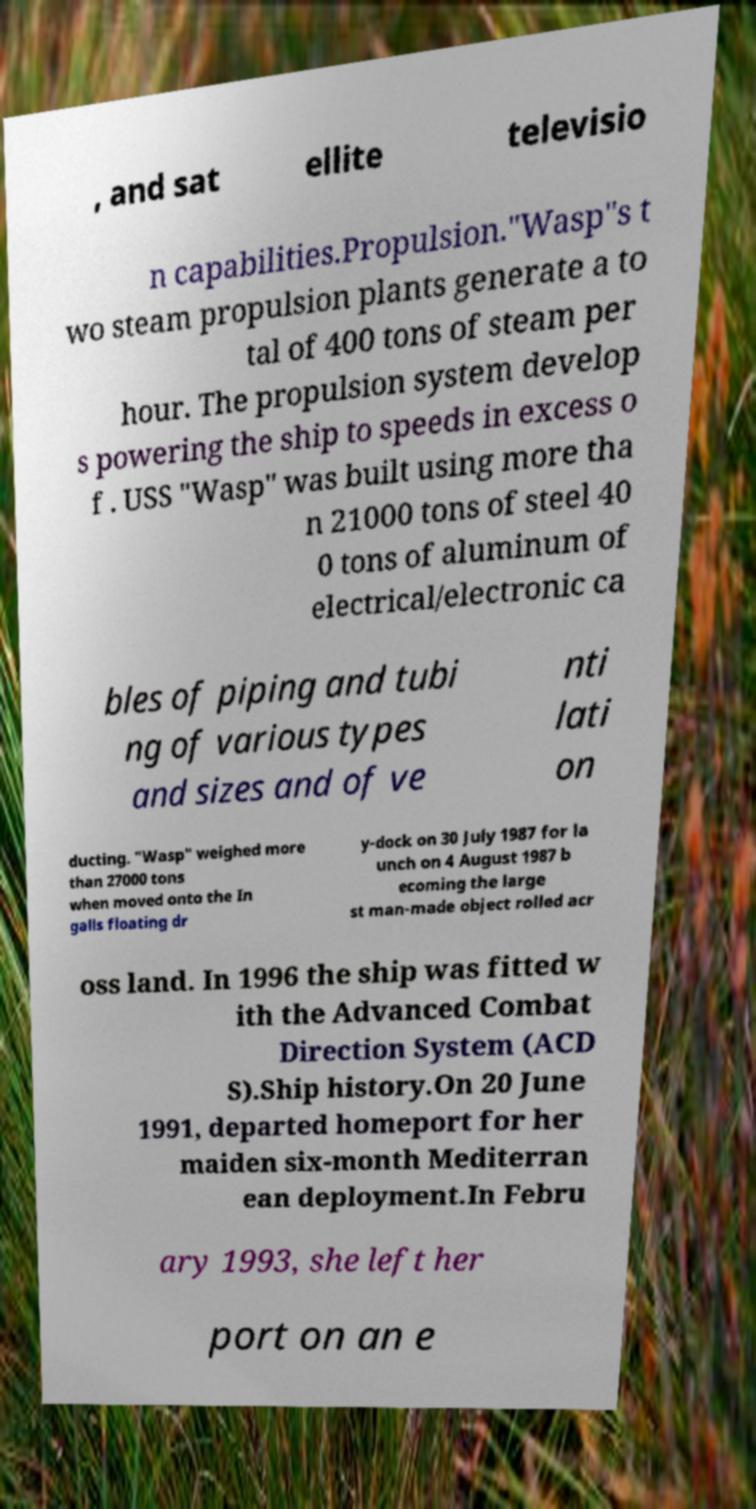Could you extract and type out the text from this image? , and sat ellite televisio n capabilities.Propulsion."Wasp"s t wo steam propulsion plants generate a to tal of 400 tons of steam per hour. The propulsion system develop s powering the ship to speeds in excess o f . USS "Wasp" was built using more tha n 21000 tons of steel 40 0 tons of aluminum of electrical/electronic ca bles of piping and tubi ng of various types and sizes and of ve nti lati on ducting. "Wasp" weighed more than 27000 tons when moved onto the In galls floating dr y-dock on 30 July 1987 for la unch on 4 August 1987 b ecoming the large st man-made object rolled acr oss land. In 1996 the ship was fitted w ith the Advanced Combat Direction System (ACD S).Ship history.On 20 June 1991, departed homeport for her maiden six-month Mediterran ean deployment.In Febru ary 1993, she left her port on an e 